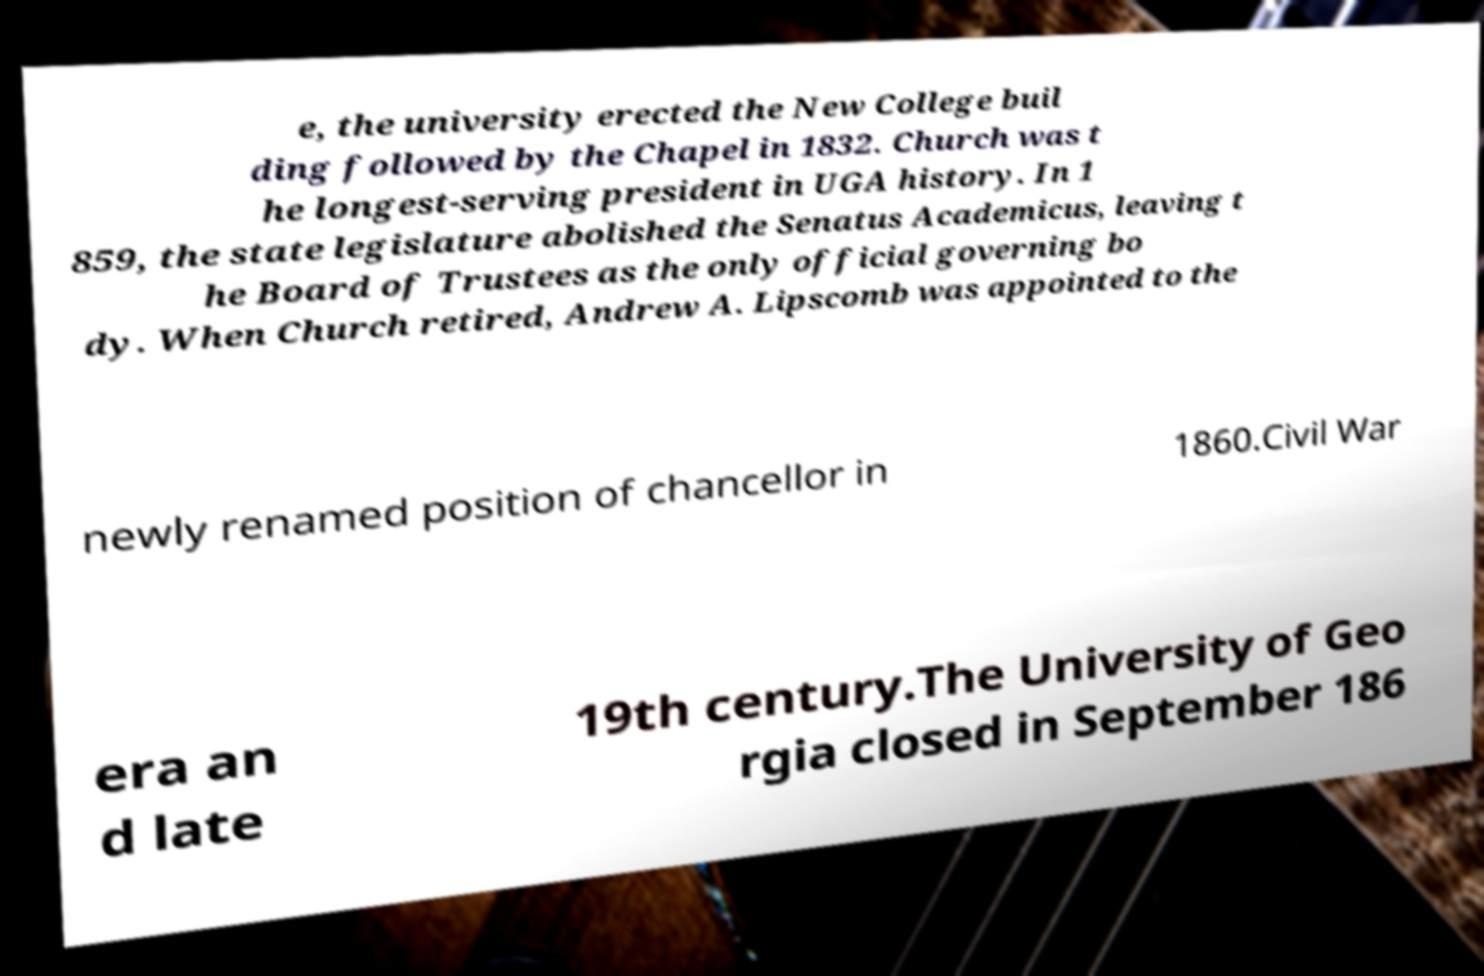Could you extract and type out the text from this image? e, the university erected the New College buil ding followed by the Chapel in 1832. Church was t he longest-serving president in UGA history. In 1 859, the state legislature abolished the Senatus Academicus, leaving t he Board of Trustees as the only official governing bo dy. When Church retired, Andrew A. Lipscomb was appointed to the newly renamed position of chancellor in 1860.Civil War era an d late 19th century.The University of Geo rgia closed in September 186 